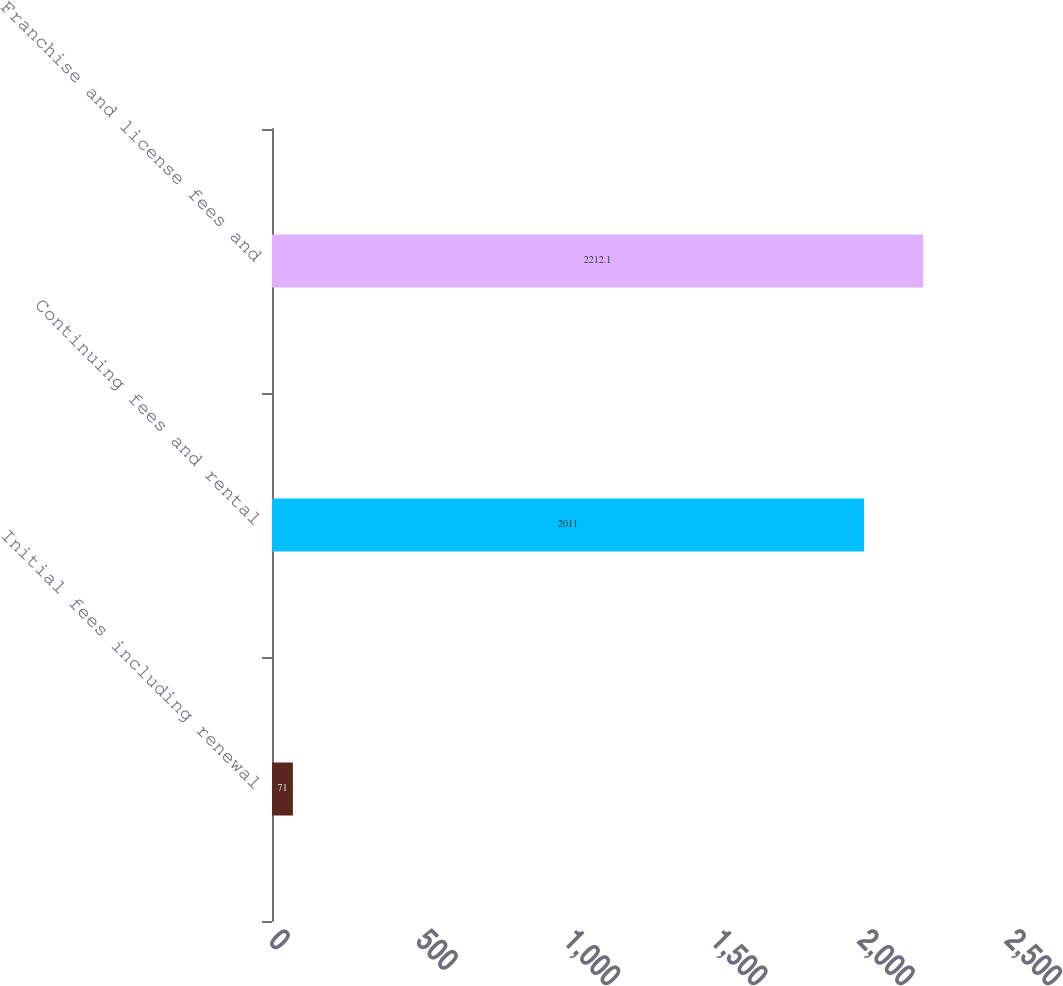<chart> <loc_0><loc_0><loc_500><loc_500><bar_chart><fcel>Initial fees including renewal<fcel>Continuing fees and rental<fcel>Franchise and license fees and<nl><fcel>71<fcel>2011<fcel>2212.1<nl></chart> 